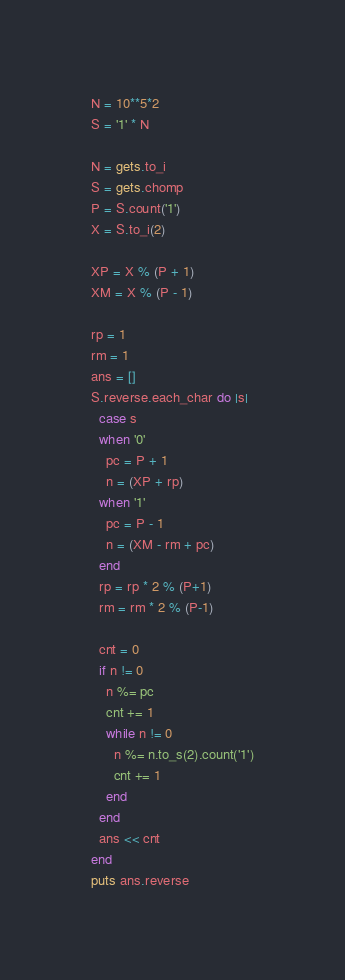<code> <loc_0><loc_0><loc_500><loc_500><_Ruby_>N = 10**5*2
S = '1' * N

N = gets.to_i
S = gets.chomp
P = S.count('1')
X = S.to_i(2)

XP = X % (P + 1)
XM = X % (P - 1)

rp = 1
rm = 1
ans = []
S.reverse.each_char do |s|
  case s
  when '0'
    pc = P + 1
    n = (XP + rp)
  when '1'
    pc = P - 1
    n = (XM - rm + pc)
  end
  rp = rp * 2 % (P+1)
  rm = rm * 2 % (P-1)

  cnt = 0
  if n != 0
    n %= pc
    cnt += 1
    while n != 0
      n %= n.to_s(2).count('1')
      cnt += 1
    end
  end
  ans << cnt
end
puts ans.reverse</code> 